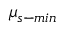<formula> <loc_0><loc_0><loc_500><loc_500>\mu _ { s - \min }</formula> 